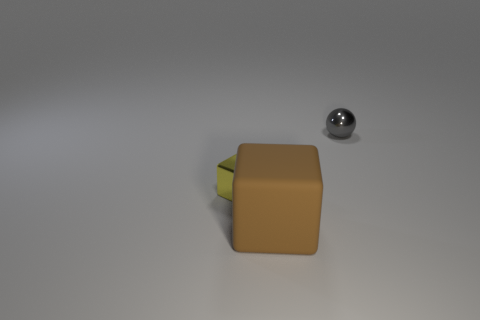Add 3 purple objects. How many objects exist? 6 Subtract all balls. How many objects are left? 2 Subtract all yellow objects. Subtract all large rubber cubes. How many objects are left? 1 Add 1 yellow blocks. How many yellow blocks are left? 2 Add 3 metallic things. How many metallic things exist? 5 Subtract 1 yellow blocks. How many objects are left? 2 